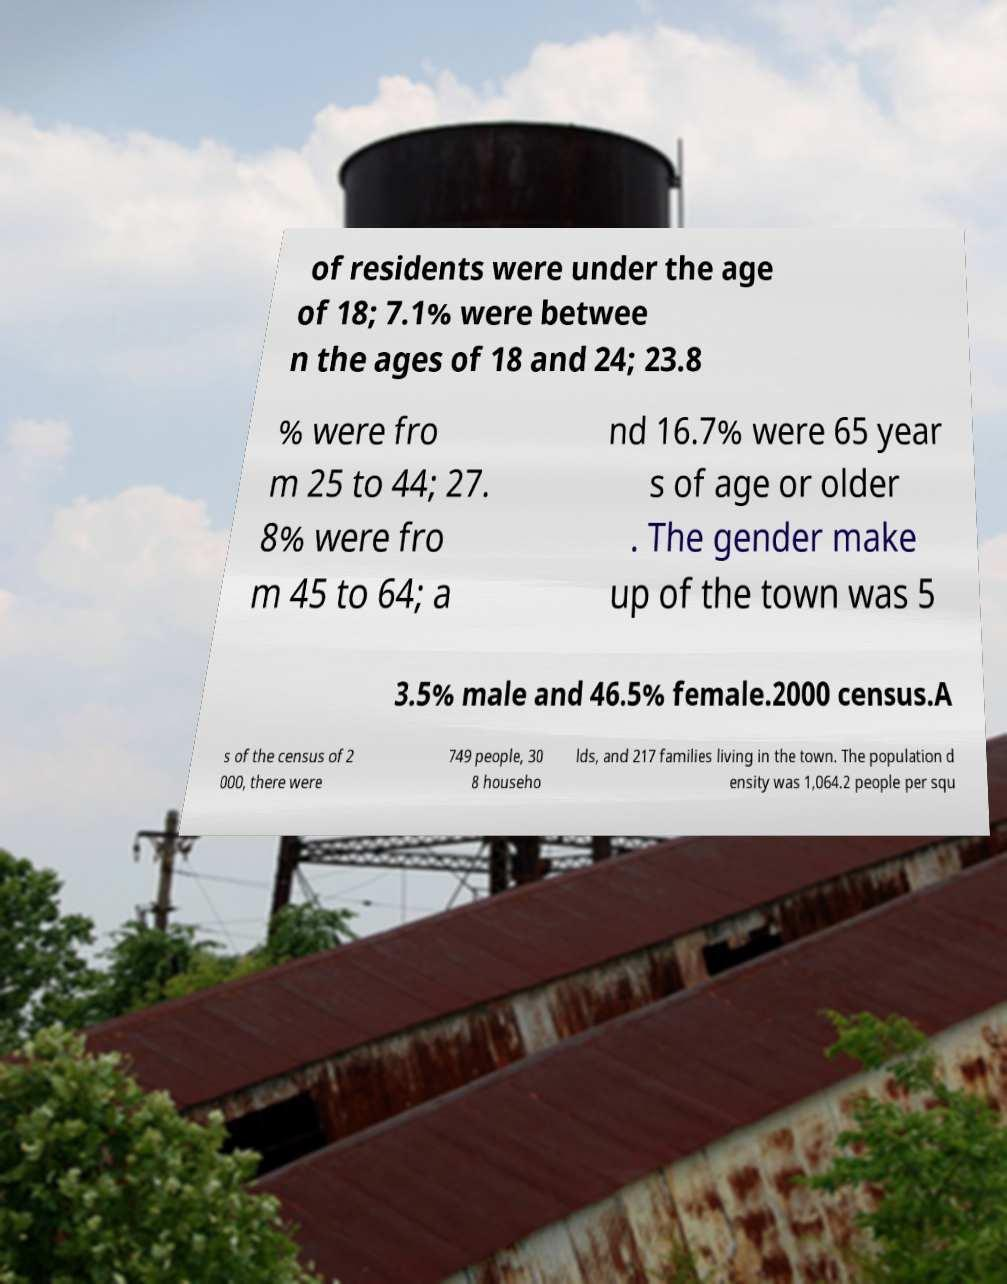Please read and relay the text visible in this image. What does it say? of residents were under the age of 18; 7.1% were betwee n the ages of 18 and 24; 23.8 % were fro m 25 to 44; 27. 8% were fro m 45 to 64; a nd 16.7% were 65 year s of age or older . The gender make up of the town was 5 3.5% male and 46.5% female.2000 census.A s of the census of 2 000, there were 749 people, 30 8 househo lds, and 217 families living in the town. The population d ensity was 1,064.2 people per squ 